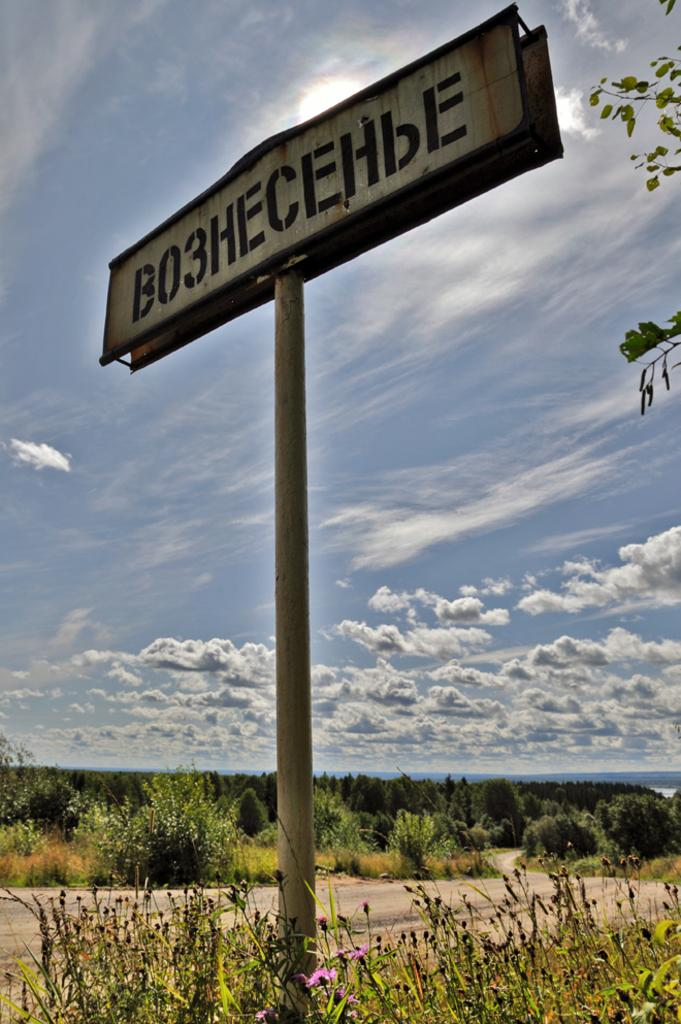What is the main object in the image? There is a board on a pole in the image. What type of vegetation can be seen in the image? There are plants and leaves visible in the image. What is the background of the image composed of? The background of the image includes grass, plants, and the sky. What can be seen in the sky in the image? Clouds are present in the sky in the image. How does the emotion of hope manifest itself in the image? The image does not depict emotions or feelings, so it is not possible to determine how hope might be present. 